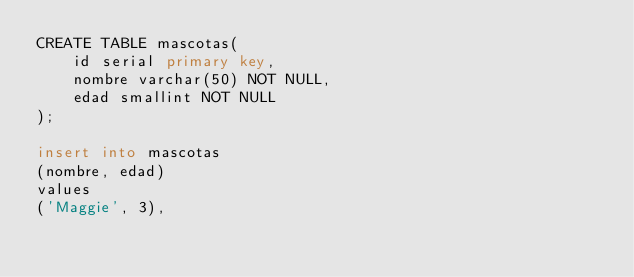Convert code to text. <code><loc_0><loc_0><loc_500><loc_500><_SQL_>CREATE TABLE mascotas(
	id serial primary key,
	nombre varchar(50) NOT NULL,
	edad smallint NOT NULL
);

insert into mascotas
(nombre, edad)
values
('Maggie', 3),</code> 